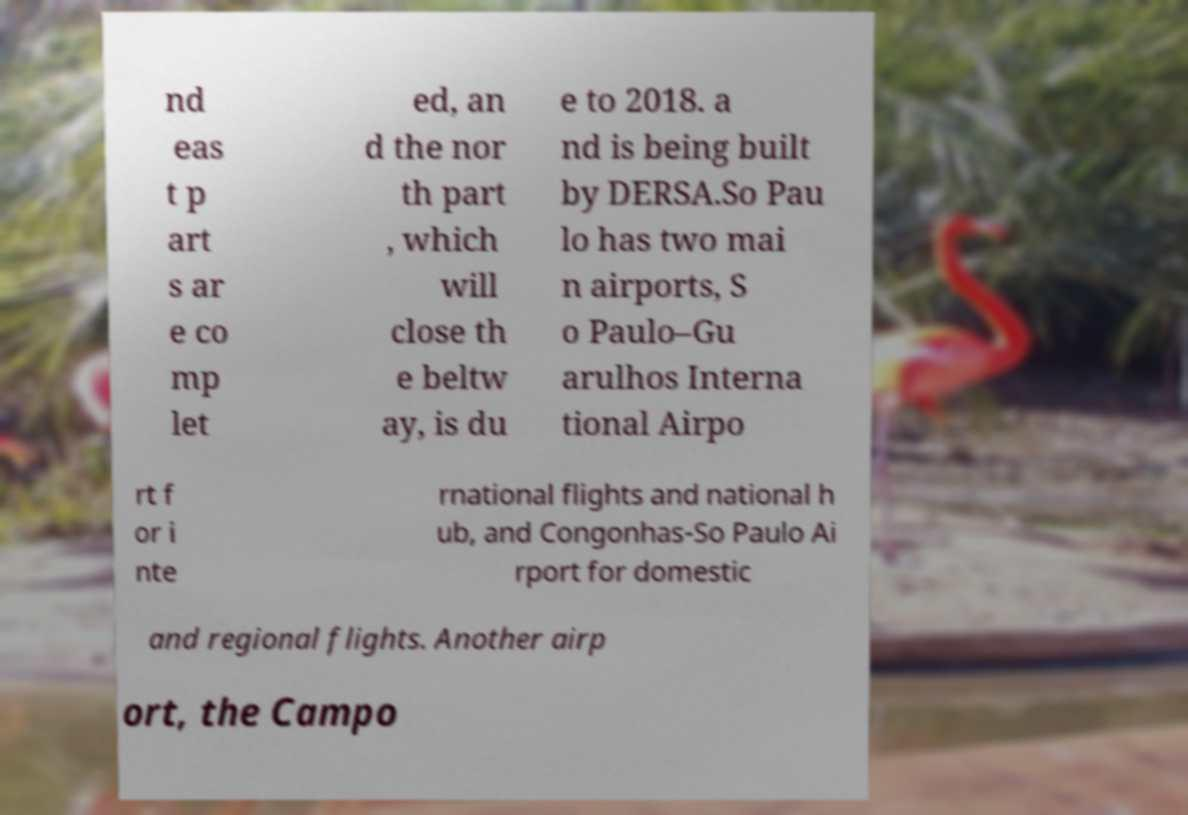Can you accurately transcribe the text from the provided image for me? nd eas t p art s ar e co mp let ed, an d the nor th part , which will close th e beltw ay, is du e to 2018. a nd is being built by DERSA.So Pau lo has two mai n airports, S o Paulo–Gu arulhos Interna tional Airpo rt f or i nte rnational flights and national h ub, and Congonhas-So Paulo Ai rport for domestic and regional flights. Another airp ort, the Campo 